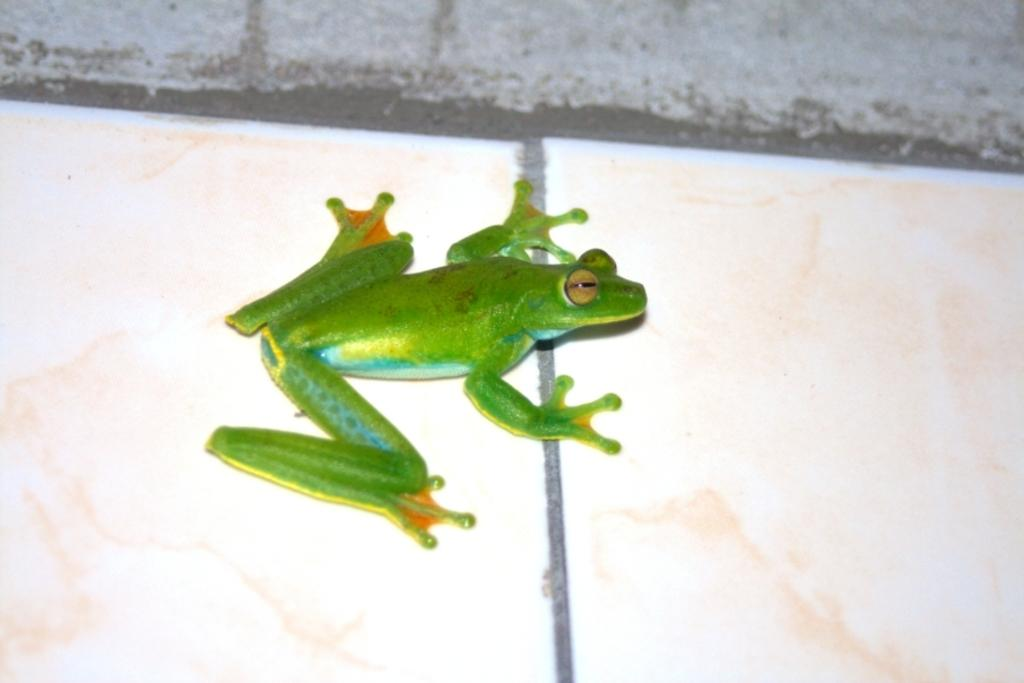What type of animal is in the image? There is a green frog in the image. What is the frog resting on or touching in the image? The frog is on a surface in the image. What type of milk is being poured into the frog's mouth in the image? There is no milk or pouring action depicted in the image; it only shows a green frog on a surface. 